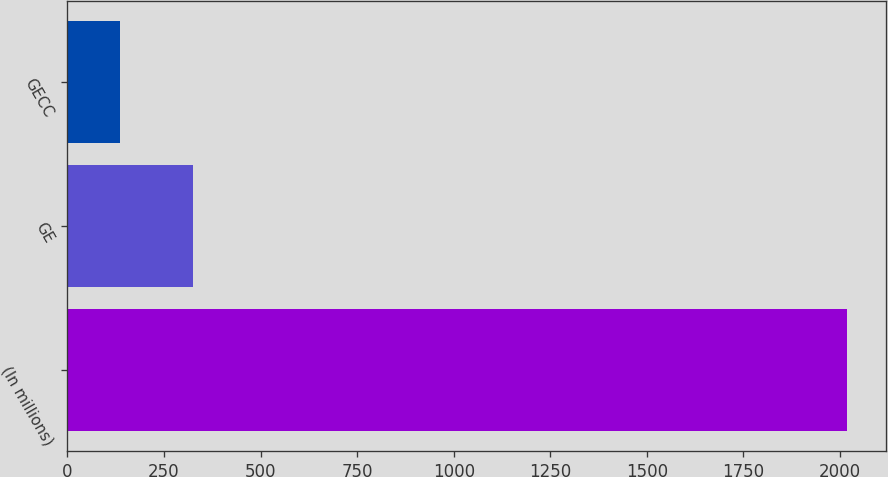<chart> <loc_0><loc_0><loc_500><loc_500><bar_chart><fcel>(In millions)<fcel>GE<fcel>GECC<nl><fcel>2017<fcel>324.1<fcel>136<nl></chart> 